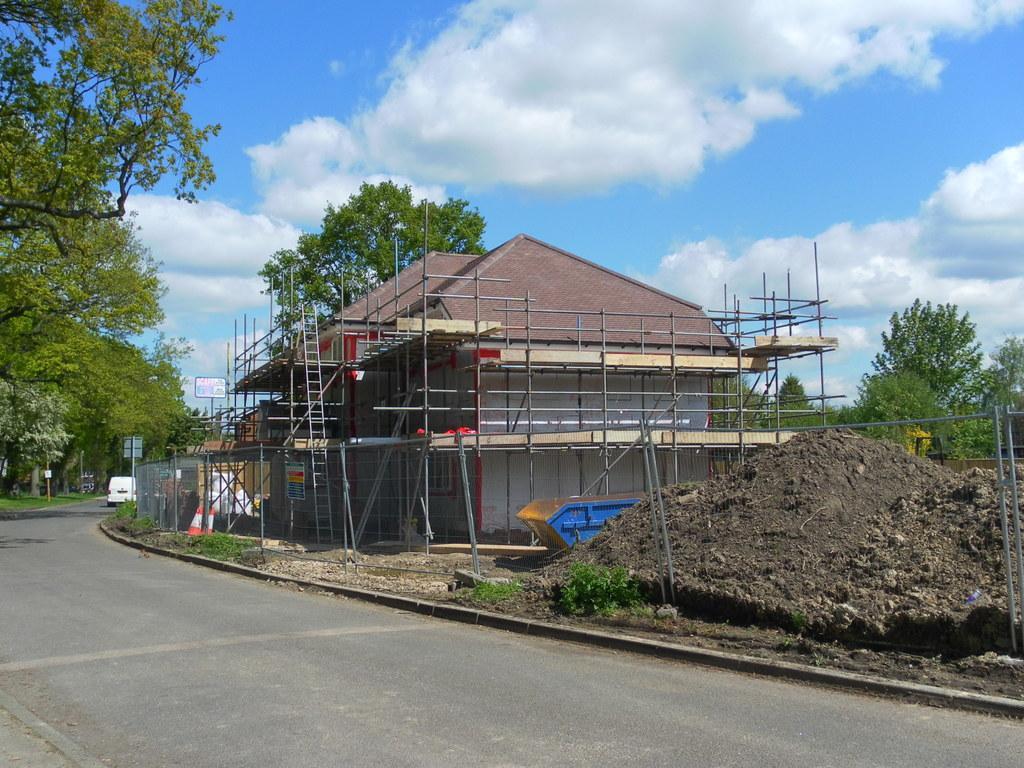Describe this image in one or two sentences. At the bottom of the image there is road. Behind the road to the right side there is a construction of house with rods, ladders and roof of the house. At the right corner of the image there is sand on the ground. In the background there are trees and poles with sign boards. At the top of the image there is a sky with clouds. 